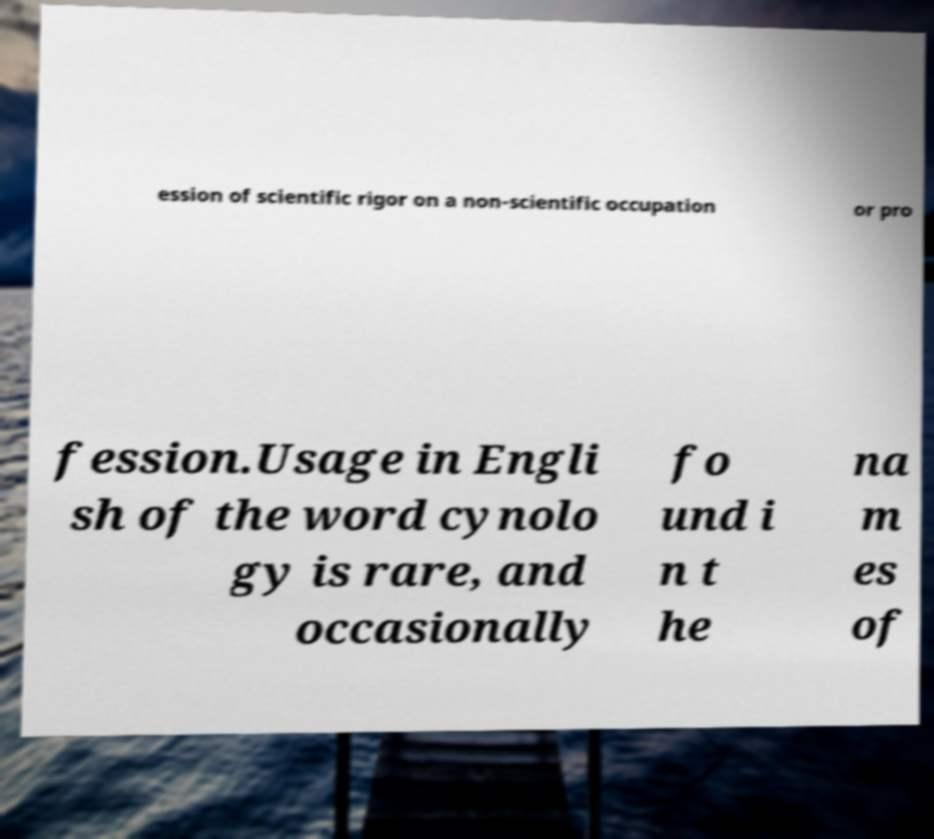What messages or text are displayed in this image? I need them in a readable, typed format. ession of scientific rigor on a non-scientific occupation or pro fession.Usage in Engli sh of the word cynolo gy is rare, and occasionally fo und i n t he na m es of 